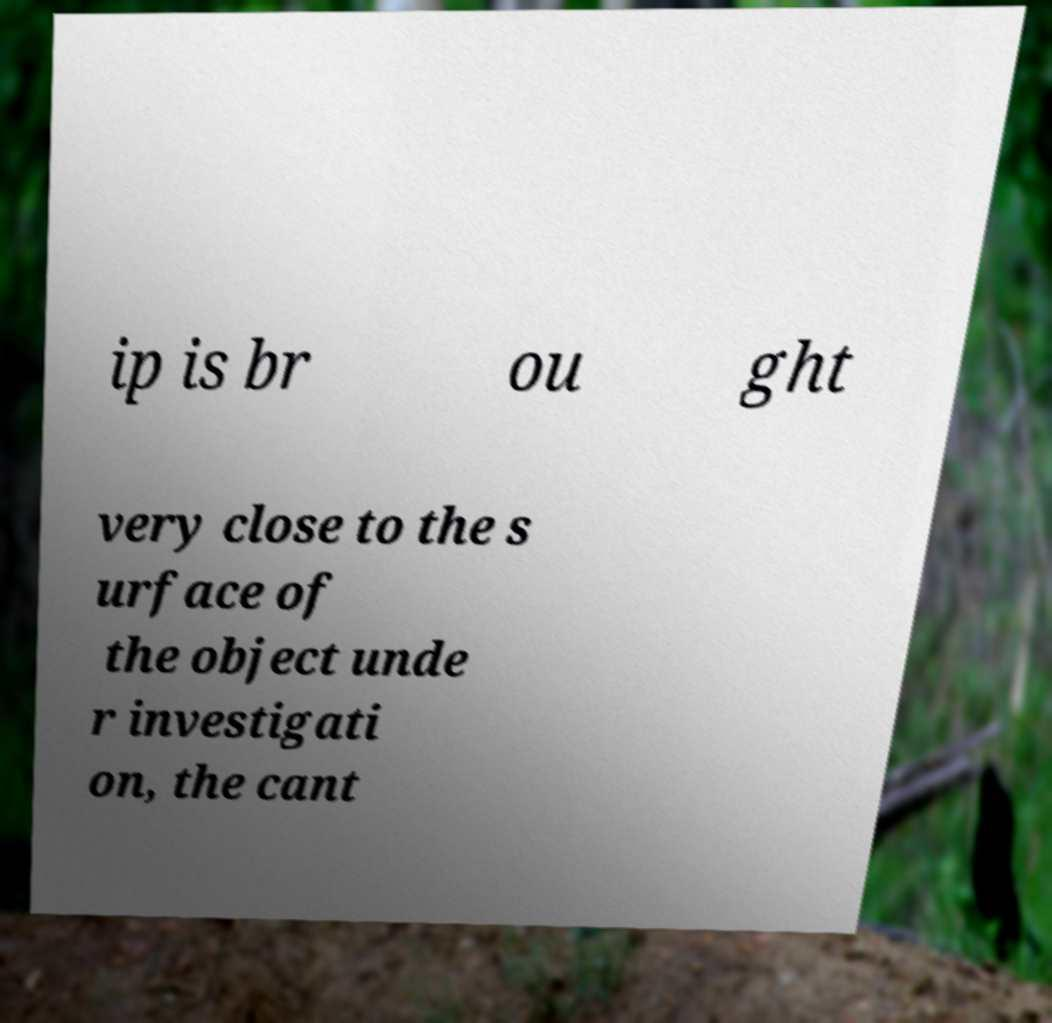For documentation purposes, I need the text within this image transcribed. Could you provide that? ip is br ou ght very close to the s urface of the object unde r investigati on, the cant 